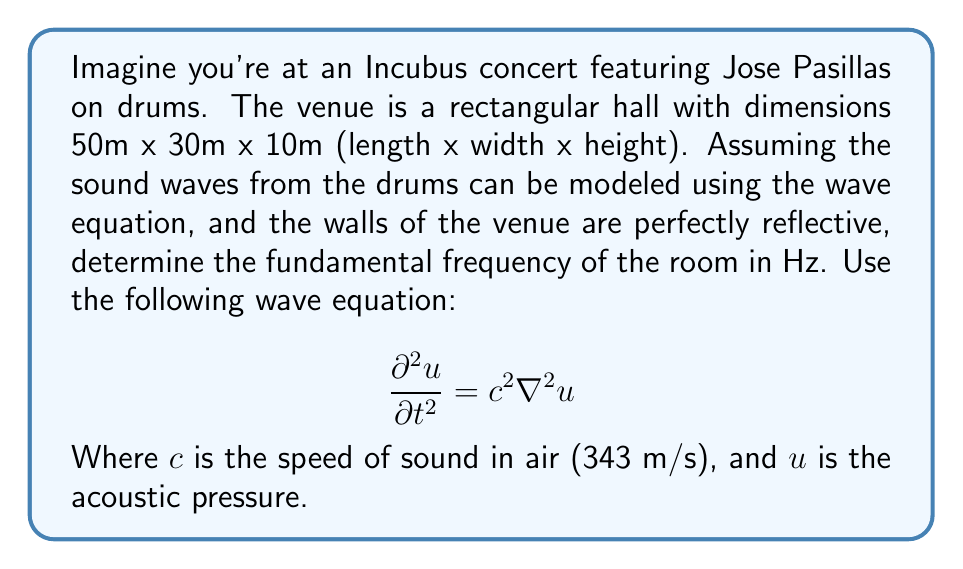Show me your answer to this math problem. To solve this problem, we need to follow these steps:

1) For a rectangular room with perfectly reflective walls, we can use the solution to the wave equation in the form:

   $$u(x,y,z,t) = A \cos(k_x x) \cos(k_y y) \cos(k_z z) e^{i\omega t}$$

   where $k_x$, $k_y$, and $k_z$ are the wavenumbers in each direction, and $\omega$ is the angular frequency.

2) The boundary conditions for perfectly reflective walls require that the normal derivative of $u$ is zero at the walls. This leads to:

   $$k_x = \frac{n_x \pi}{L_x}, k_y = \frac{n_y \pi}{L_y}, k_z = \frac{n_z \pi}{L_z}$$

   where $n_x$, $n_y$, and $n_z$ are non-negative integers, and $L_x$, $L_y$, and $L_z$ are the room dimensions.

3) The dispersion relation for the wave equation connects $\omega$ and $k$:

   $$\omega^2 = c^2(k_x^2 + k_y^2 + k_z^2)$$

4) Substituting the expressions for $k_x$, $k_y$, and $k_z$:

   $$\omega^2 = c^2 \pi^2 \left(\frac{n_x^2}{L_x^2} + \frac{n_y^2}{L_y^2} + \frac{n_z^2}{L_z^2}\right)$$

5) The fundamental frequency corresponds to the lowest non-zero frequency, which occurs when $n_x = 1$, $n_y = 0$, and $n_z = 0$. Therefore:

   $$\omega^2 = c^2 \pi^2 \left(\frac{1^2}{L_x^2} + \frac{0^2}{L_y^2} + \frac{0^2}{L_z^2}\right) = \frac{c^2 \pi^2}{L_x^2}$$

6) Solving for $\omega$:

   $$\omega = \frac{c\pi}{L_x}$$

7) Converting angular frequency to regular frequency:

   $$f = \frac{\omega}{2\pi} = \frac{c}{2L_x}$$

8) Substituting the values:

   $$f = \frac{343 \text{ m/s}}{2 \cdot 50 \text{ m}} = 3.43 \text{ Hz}$$

Thus, the fundamental frequency of the room is approximately 3.43 Hz.
Answer: The fundamental frequency of the concert venue is approximately 3.43 Hz. 